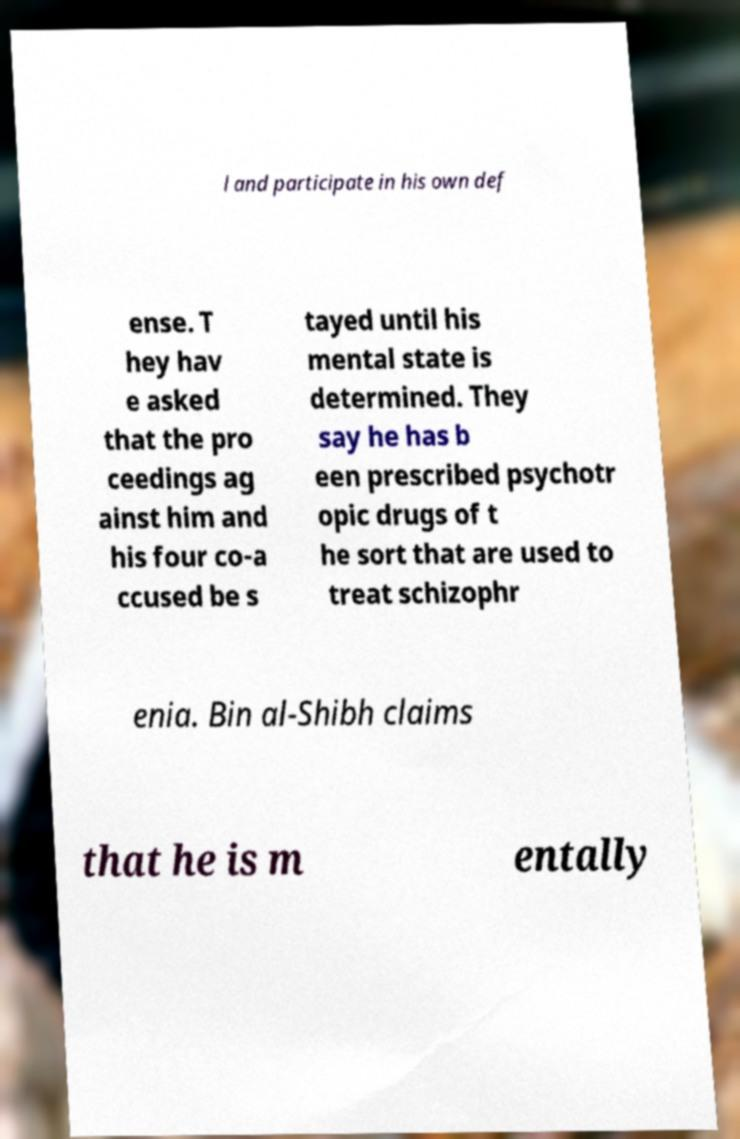Please read and relay the text visible in this image. What does it say? l and participate in his own def ense. T hey hav e asked that the pro ceedings ag ainst him and his four co-a ccused be s tayed until his mental state is determined. They say he has b een prescribed psychotr opic drugs of t he sort that are used to treat schizophr enia. Bin al-Shibh claims that he is m entally 